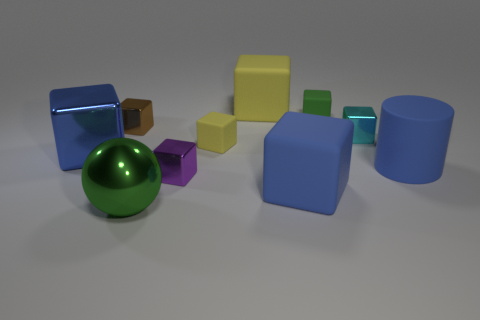Subtract all blue shiny cubes. How many cubes are left? 7 Subtract all brown cubes. How many cubes are left? 7 Subtract all cylinders. How many objects are left? 9 Subtract 6 blocks. How many blocks are left? 2 Subtract all gray cylinders. Subtract all red spheres. How many cylinders are left? 1 Subtract all yellow cylinders. How many blue blocks are left? 2 Subtract all large metallic spheres. Subtract all green metal cylinders. How many objects are left? 9 Add 4 balls. How many balls are left? 5 Add 6 big blue matte things. How many big blue matte things exist? 8 Subtract 0 red blocks. How many objects are left? 10 